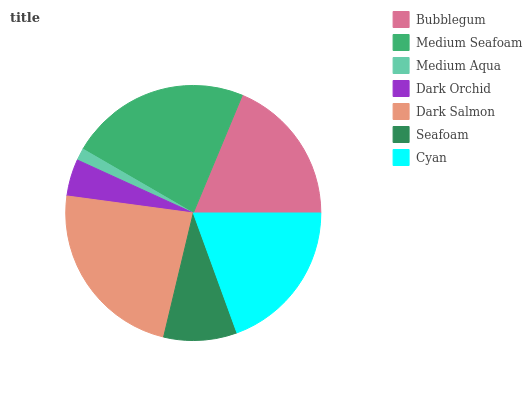Is Medium Aqua the minimum?
Answer yes or no. Yes. Is Dark Salmon the maximum?
Answer yes or no. Yes. Is Medium Seafoam the minimum?
Answer yes or no. No. Is Medium Seafoam the maximum?
Answer yes or no. No. Is Medium Seafoam greater than Bubblegum?
Answer yes or no. Yes. Is Bubblegum less than Medium Seafoam?
Answer yes or no. Yes. Is Bubblegum greater than Medium Seafoam?
Answer yes or no. No. Is Medium Seafoam less than Bubblegum?
Answer yes or no. No. Is Bubblegum the high median?
Answer yes or no. Yes. Is Bubblegum the low median?
Answer yes or no. Yes. Is Medium Seafoam the high median?
Answer yes or no. No. Is Cyan the low median?
Answer yes or no. No. 